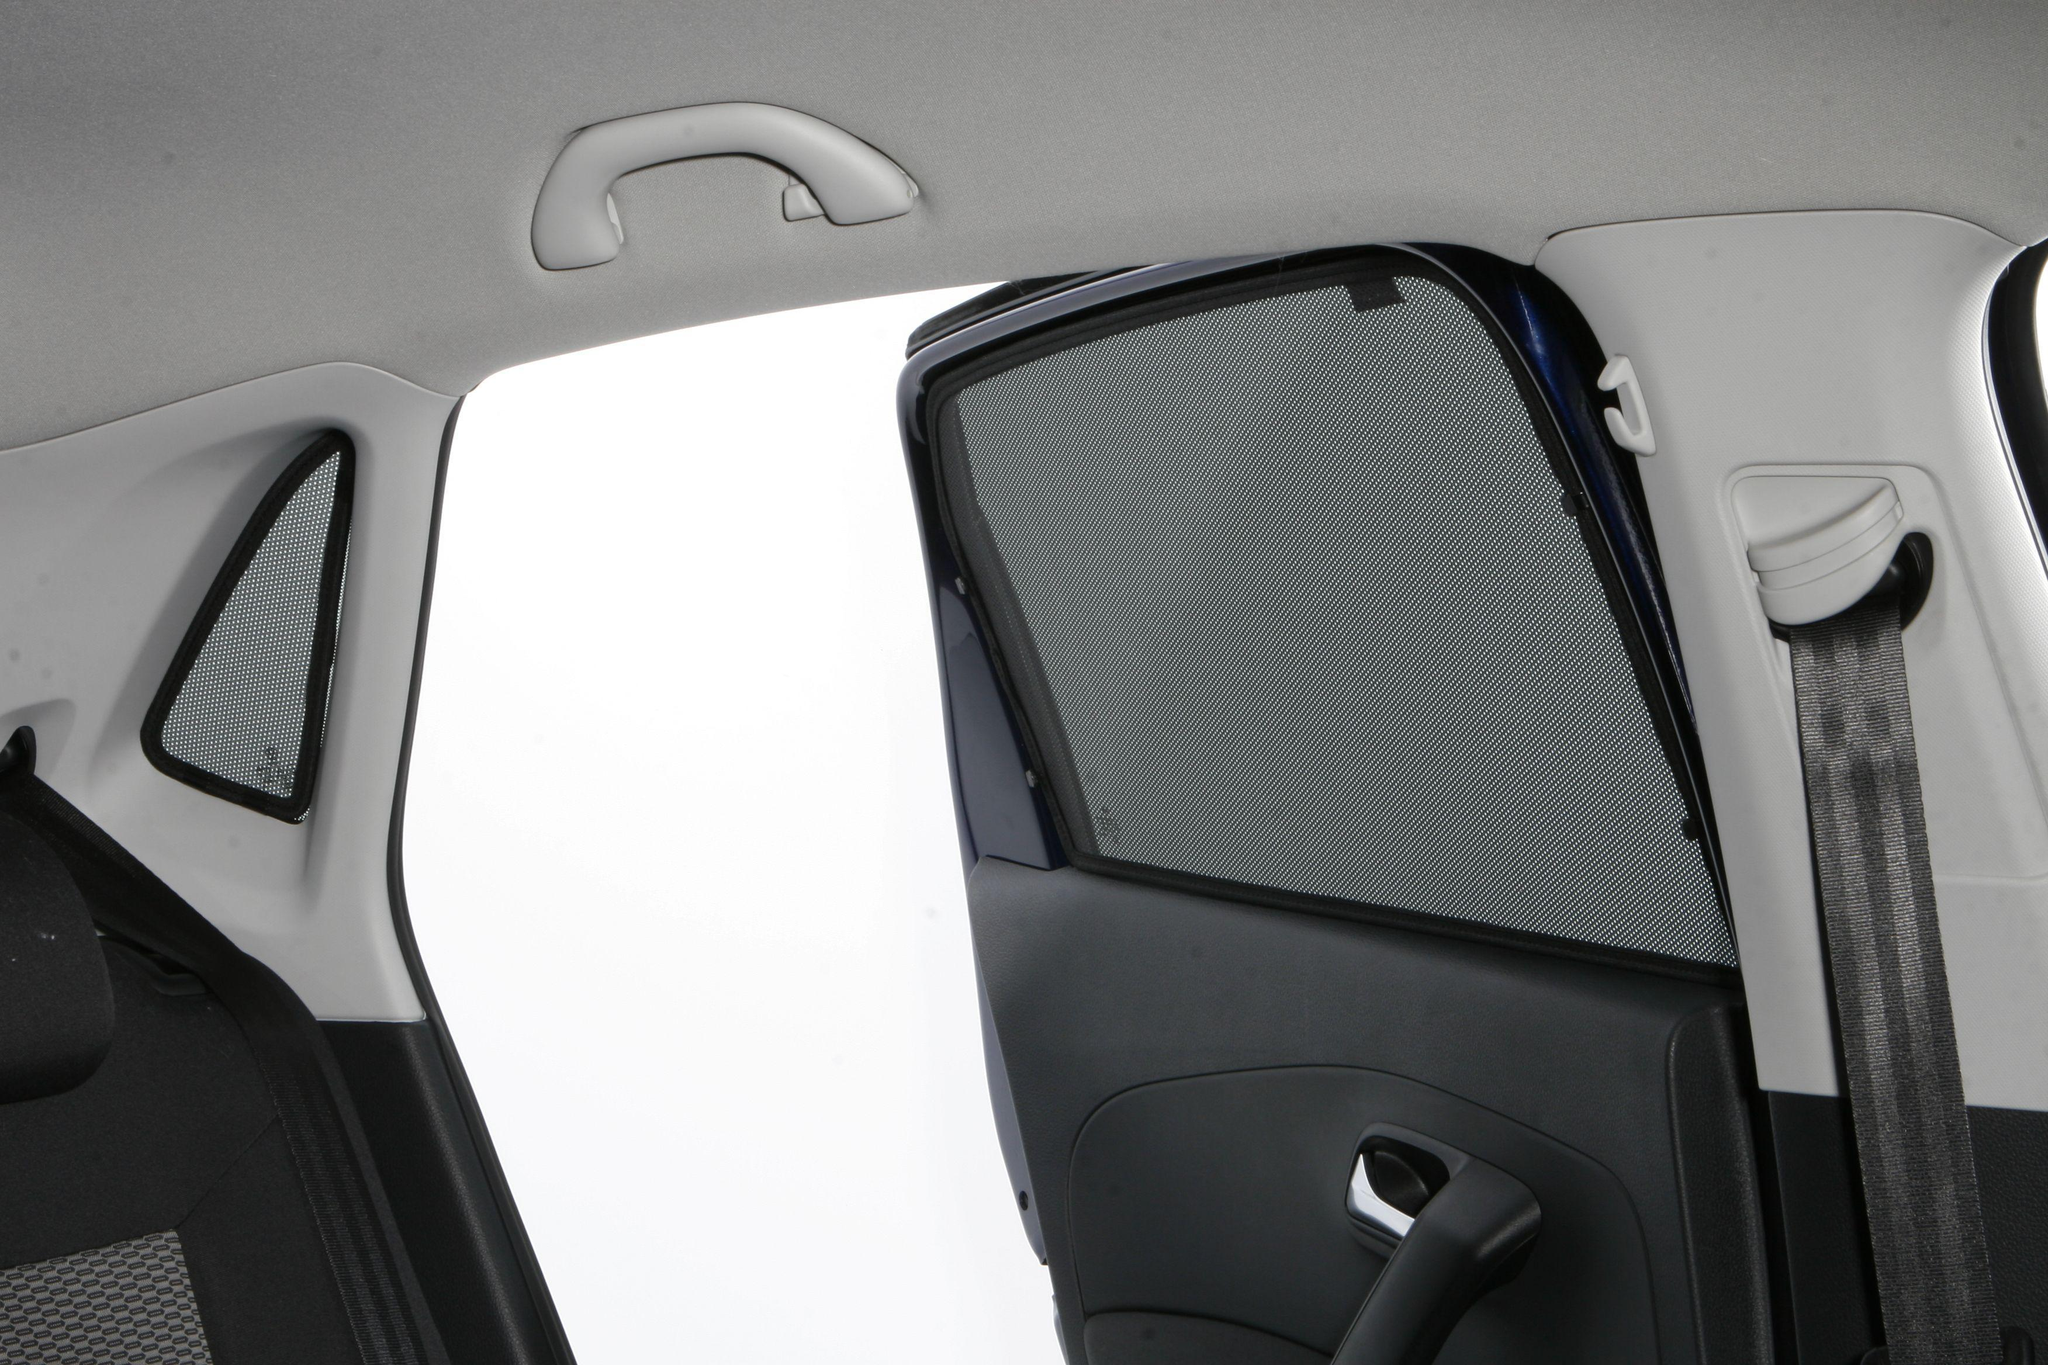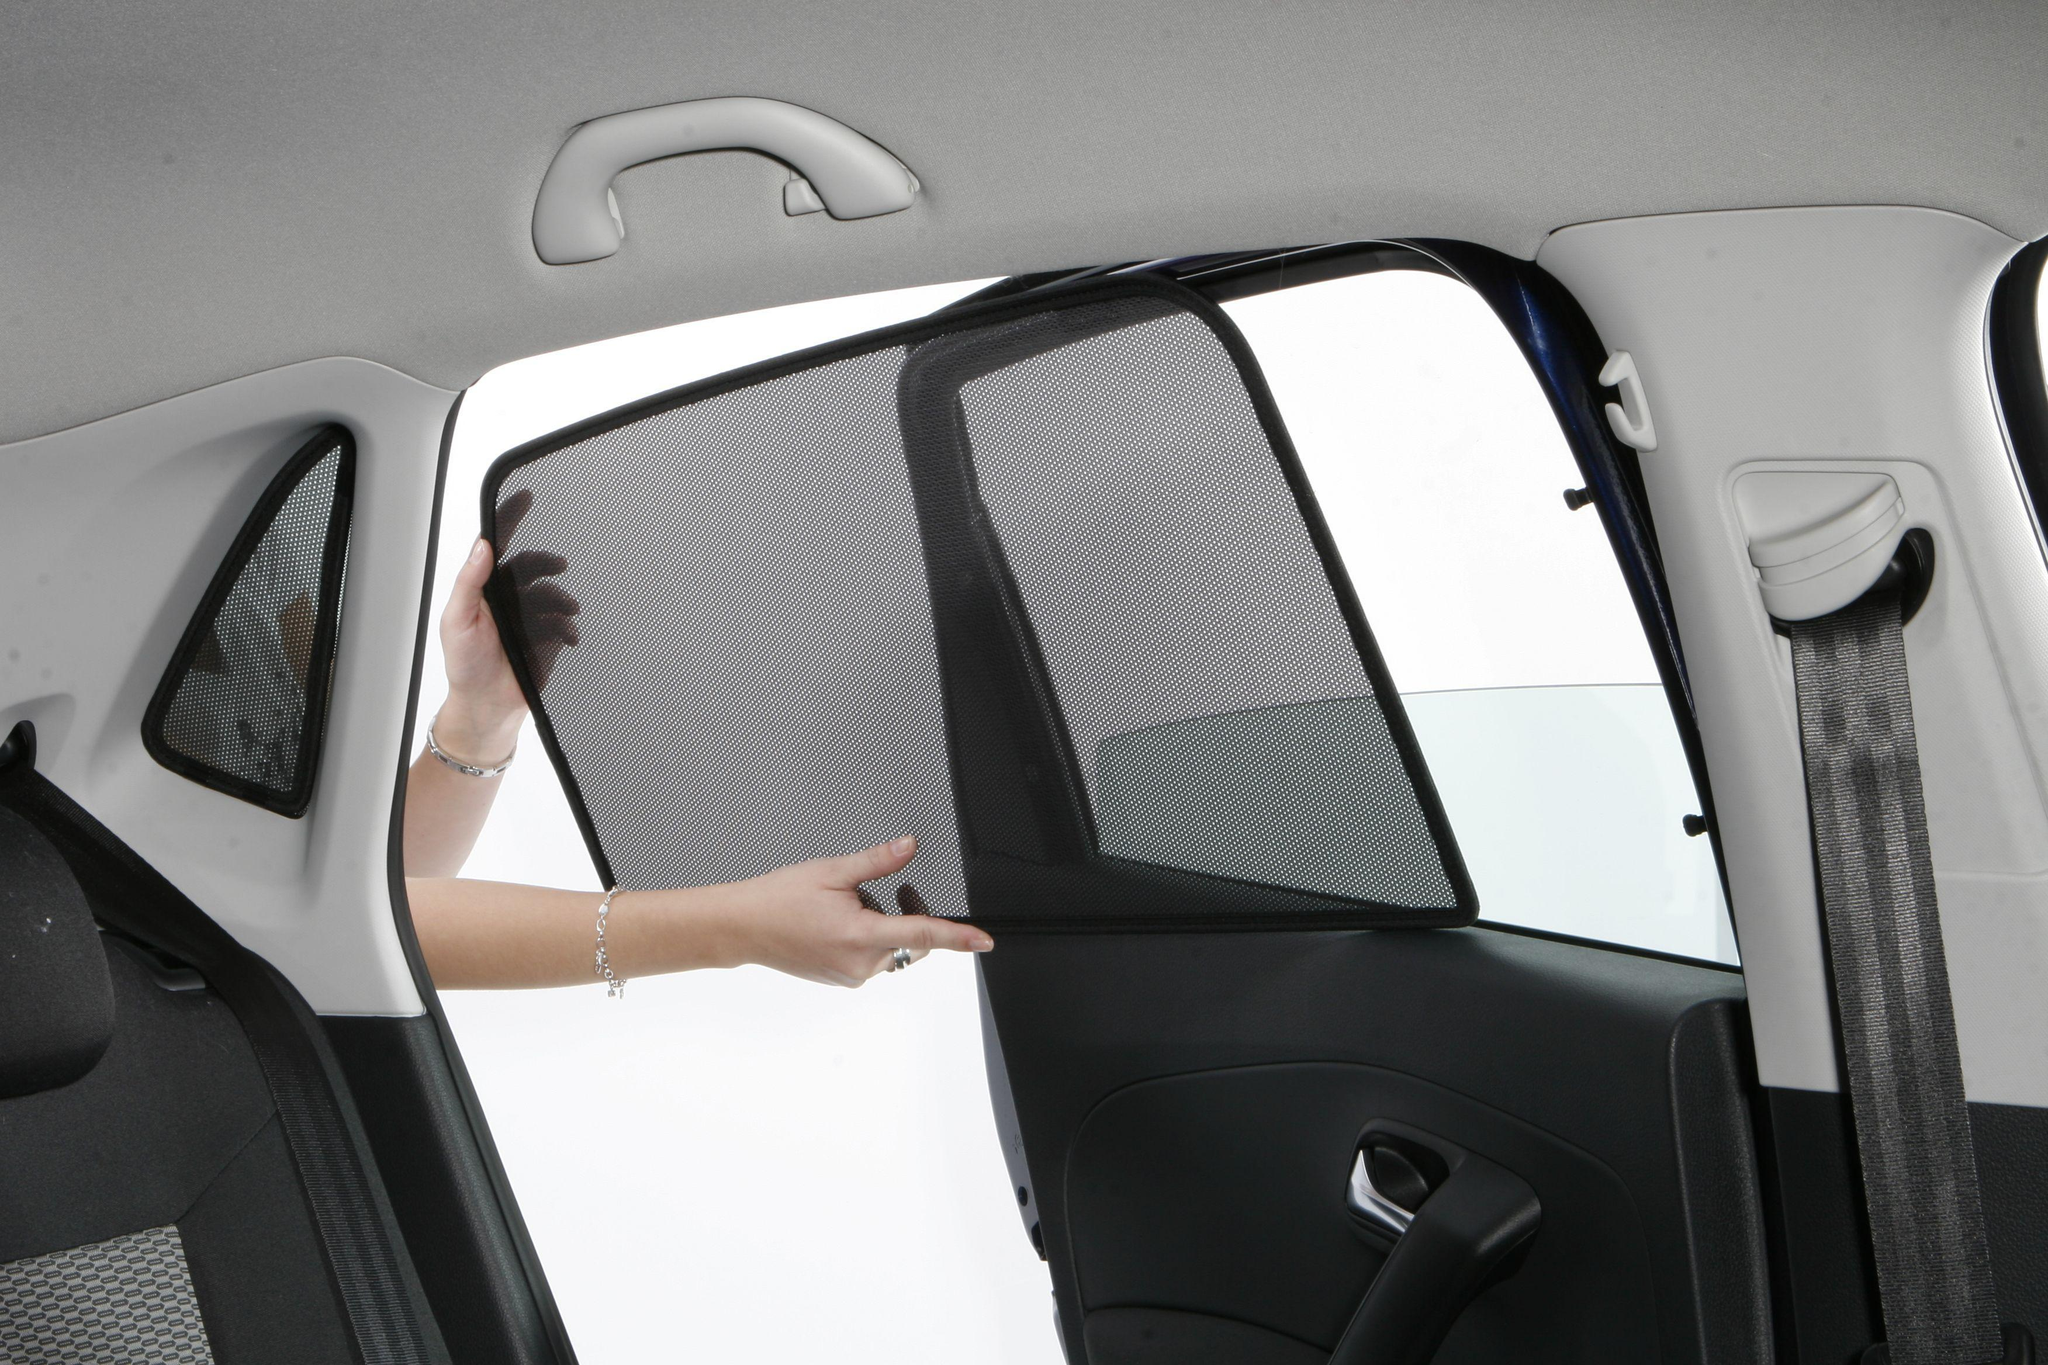The first image is the image on the left, the second image is the image on the right. Evaluate the accuracy of this statement regarding the images: "A human arm is visible on the right image.". Is it true? Answer yes or no. Yes. 